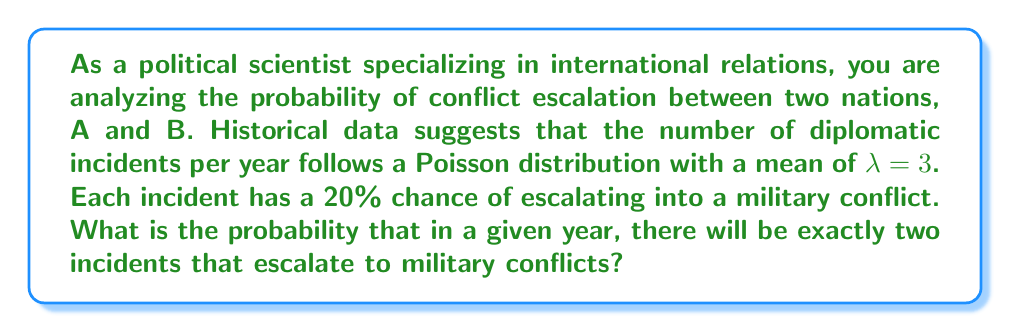Can you answer this question? To solve this problem, we need to use a combination of the Poisson distribution and the Binomial distribution.

1. First, we need to find the probability of having exactly k incidents in a year, which follows a Poisson distribution:

   $$ P(X = k) = \frac{e^{-λ} λ^k}{k!} $$

   where λ = 3 (mean number of incidents per year)

2. Then, we need to calculate the probability of exactly 2 out of k incidents escalating, which follows a Binomial distribution:

   $$ P(Y = 2 | X = k) = \binom{k}{2} p^2 (1-p)^{k-2} $$

   where p = 0.20 (probability of an incident escalating)

3. We need to consider all possible numbers of incidents (k) that could result in exactly 2 escalations. This means k must be at least 2.

4. The total probability is the sum of the products of these two probabilities for all k ≥ 2:

   $$ P(Y = 2) = \sum_{k=2}^{\infty} P(X = k) \cdot P(Y = 2 | X = k) $$

5. Let's calculate the first few terms:

   For k = 2:
   $P(X = 2) = \frac{e^{-3} 3^2}{2!} = 0.2240$
   $P(Y = 2 | X = 2) = \binom{2}{2} 0.2^2 (1-0.2)^{0} = 0.04$
   $P(X = 2) \cdot P(Y = 2 | X = 2) = 0.2240 \cdot 0.04 = 0.00896$

   For k = 3:
   $P(X = 3) = \frac{e^{-3} 3^3}{3!} = 0.2240$
   $P(Y = 2 | X = 3) = \binom{3}{2} 0.2^2 (1-0.2)^{1} = 0.0768$
   $P(X = 3) \cdot P(Y = 2 | X = 3) = 0.2240 \cdot 0.0768 = 0.017203$

   For k = 4:
   $P(X = 4) = \frac{e^{-3} 3^4}{4!} = 0.1680$
   $P(Y = 2 | X = 4) = \binom{4}{2} 0.2^2 (1-0.2)^{2} = 0.0922$
   $P(X = 4) \cdot P(Y = 2 | X = 4) = 0.1680 \cdot 0.0922 = 0.015490$

6. Continuing this process and summing all terms gives us the final probability.
Answer: The probability of exactly two incidents escalating to military conflicts in a given year is approximately 0.0670 or 6.70%. 